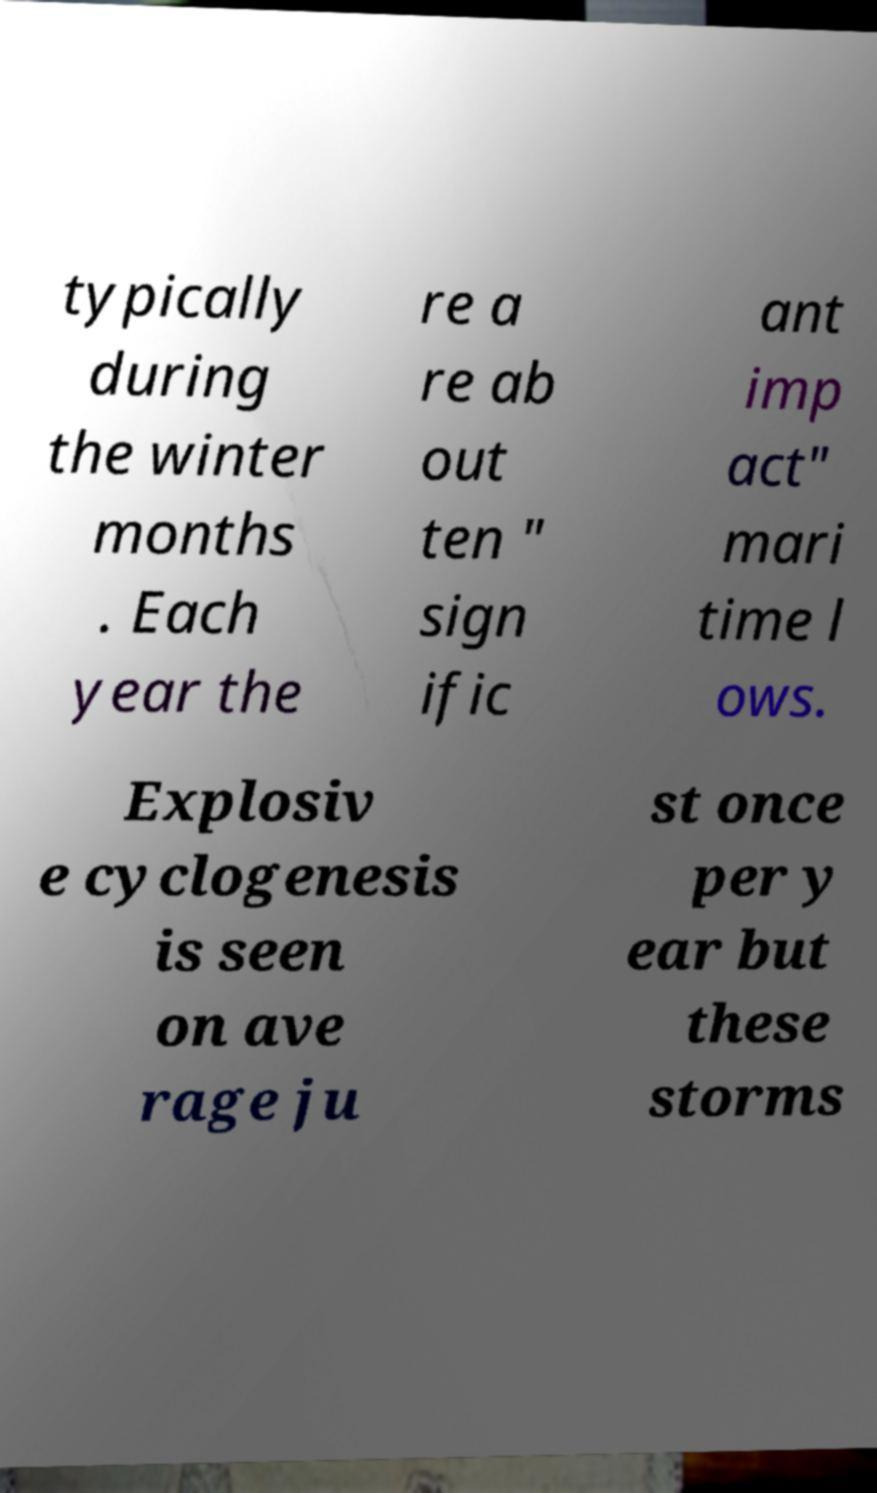For documentation purposes, I need the text within this image transcribed. Could you provide that? typically during the winter months . Each year the re a re ab out ten " sign ific ant imp act" mari time l ows. Explosiv e cyclogenesis is seen on ave rage ju st once per y ear but these storms 